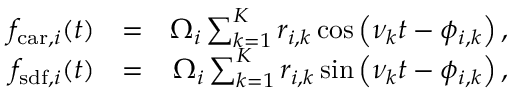Convert formula to latex. <formula><loc_0><loc_0><loc_500><loc_500>\begin{array} { r l r } { f _ { c a r , i } ( t ) } & { = } & { \Omega _ { i } \sum _ { k = 1 } ^ { K } r _ { i , k } \cos \left ( \nu _ { k } t - \phi _ { i , k } \right ) , } \\ { f _ { s d f , i } ( t ) } & { = } & { \Omega _ { i } \sum _ { k = 1 } ^ { K } r _ { i , k } \sin \left ( \nu _ { k } t - \phi _ { i , k } \right ) , } \end{array}</formula> 